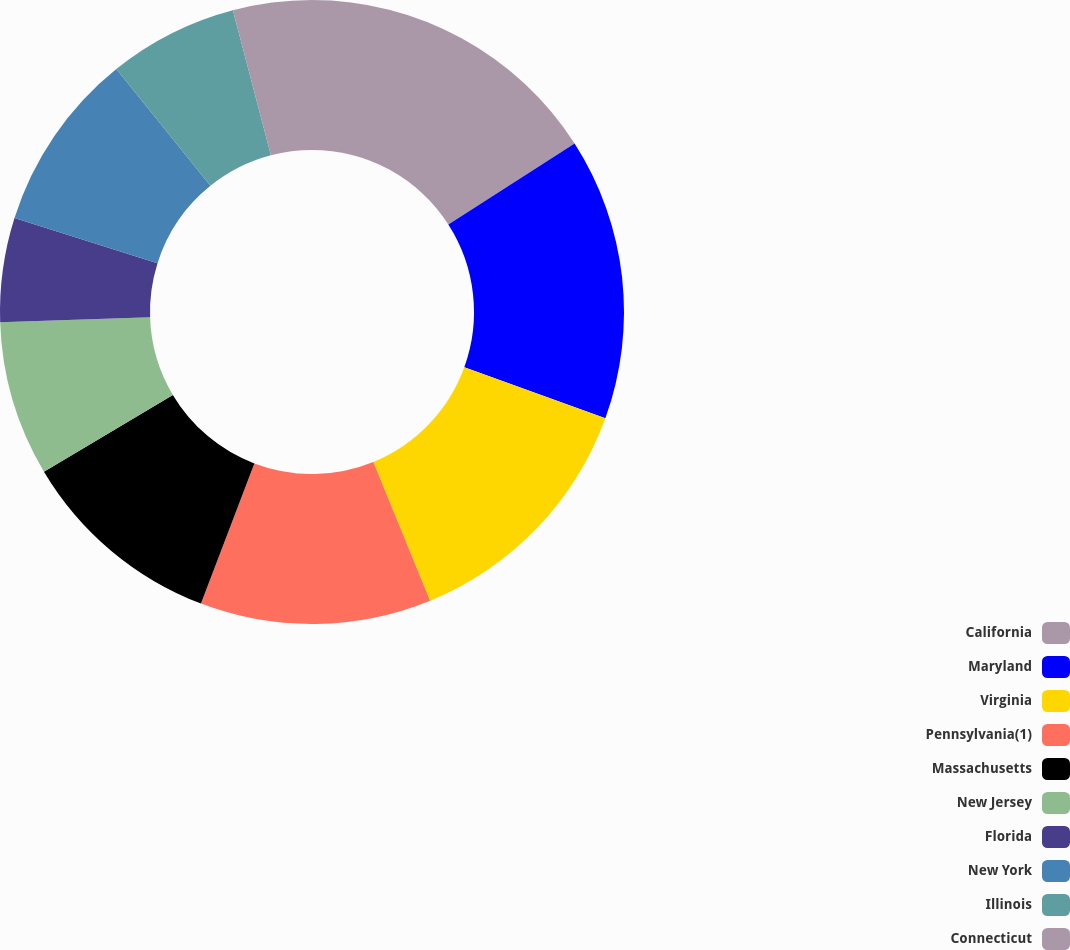<chart> <loc_0><loc_0><loc_500><loc_500><pie_chart><fcel>California<fcel>Maryland<fcel>Virginia<fcel>Pennsylvania(1)<fcel>Massachusetts<fcel>New Jersey<fcel>Florida<fcel>New York<fcel>Illinois<fcel>Connecticut<nl><fcel>15.92%<fcel>14.61%<fcel>13.29%<fcel>11.97%<fcel>10.66%<fcel>8.03%<fcel>5.39%<fcel>9.34%<fcel>6.71%<fcel>4.08%<nl></chart> 